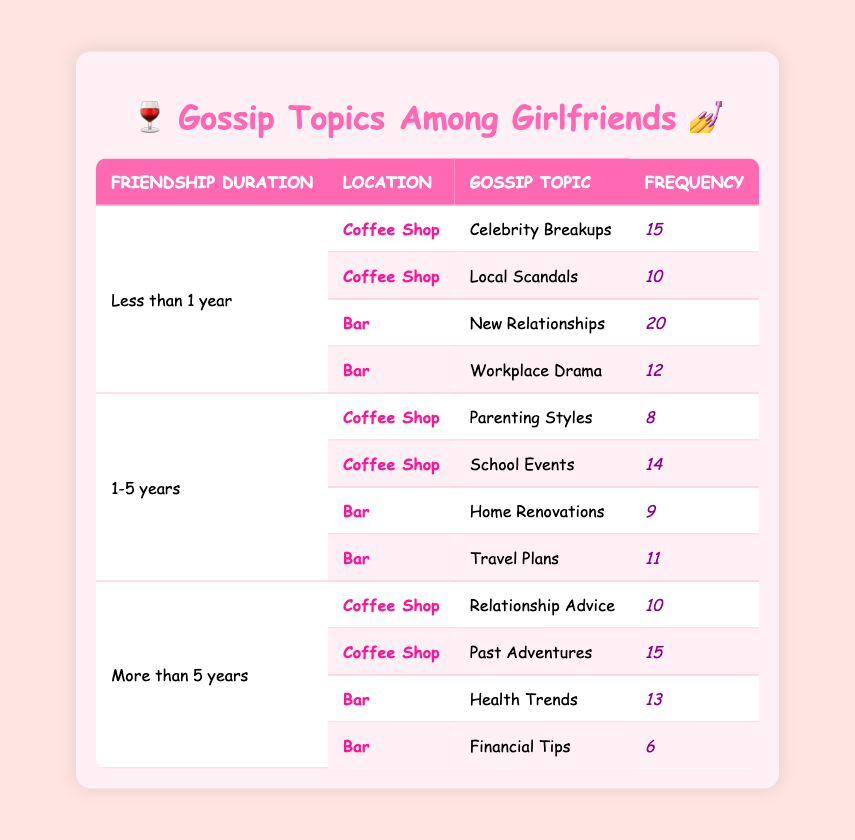What is the most frequently discussed gossip topic at the bar for friendships lasting less than one year? At the bar, "New Relationships" has the highest frequency of 20, while "Workplace Drama" has a frequency of 12. Therefore, "New Relationships," with the higher frequency, is the most frequently discussed topic.
Answer: New Relationships What is the frequency of discussing parenting styles among friends with 1-5 years of friendship at a coffee shop? For friends with 1-5 years of friendship at a coffee shop, "Parenting Styles" has a frequency of 8. This information is explicitly listed in the table.
Answer: 8 Is the frequency of discussing health trends among friends with more than 5 years of friendship at a bar greater than 10? The frequency for discussing health trends at a bar among friends with more than 5 years of friendship is 13. Since 13 is greater than 10, the statement is true.
Answer: Yes What are the two most discussed topics at the coffee shop for friendships lasting more than 5 years? At the coffee shop, for friendships lasting more than 5 years, the topics discussed are "Relationship Advice" (10) and "Past Adventures" (15). Comparing these frequencies, "Past Adventures" has the highest at 15, making it the most discussed, followed by "Relationship Advice" at 10.
Answer: Past Adventures and Relationship Advice Calculate the total frequency of gossip topics discussed at the bar for friends who have known each other for less than 1 year. The topics discussed at the bar for this duration are "New Relationships" (20) and "Workplace Drama" (12). To find the total frequency: 20 + 12 = 32.
Answer: 32 Which gossip topic is discussed least among friends with more than 5 years of friendship at a bar? Among friends with more than 5 years of friendship at a bar, the topics are "Health Trends" (13) and "Financial Tips" (6). Since 6 is the lowest frequency, "Financial Tips" is the least discussed topic.
Answer: Financial Tips What is the difference in frequency between gossip discussions about local scandals and relationship advice at the coffee shop? "Local Scandals" has a frequency of 10 and "Relationship Advice" has a frequency of 10. The difference in frequency is 10 - 10 = 0.
Answer: 0 Are more gossip topics discussed at the coffee shop compared to the bar for friendships lasting less than one year? At the coffee shop, there are 2 topics (Celebrity Breakups and Local Scandals) and at the bar, there are also 2 (New Relationships and Workplace Drama). Since both locations have the same number of topics, the statement is false.
Answer: No What is the highest frequency of a gossip topic discussed in the table, and which topic is it? The highest frequency listed in the table is 20, which corresponds to the topic "New Relationships" at the bar for friends with less than 1 year of friendship.
Answer: 20, New Relationships 